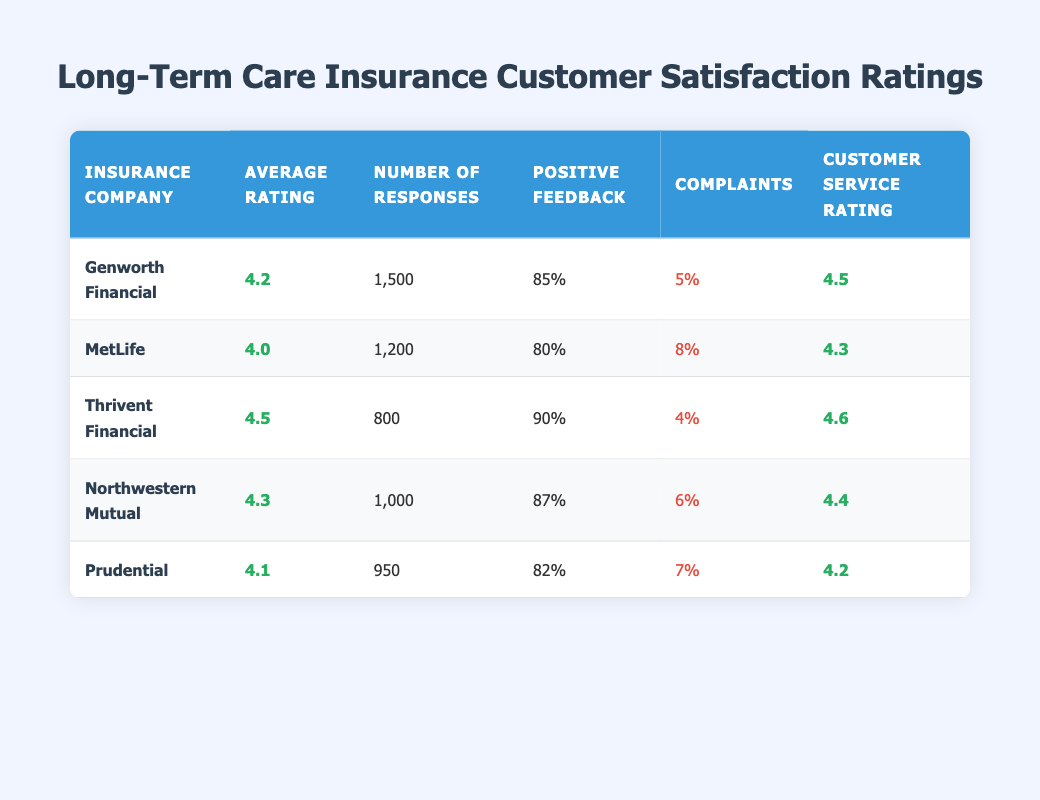What is the average rating for Genworth Financial? The table indicates that the average rating for Genworth Financial is listed under "Average Rating," which is 4.2.
Answer: 4.2 How many responses were received for Prudential? The table shows that the number of responses for Prudential is found under the "Number of Responses," and it is 950.
Answer: 950 Which insurance company received the highest customer service rating? By comparing the "Customer Service Rating" column, Thrivent Financial has the highest customer service rating at 4.6.
Answer: Thrivent Financial What is the total number of responses from all five insurance companies? To find the total, add the number of responses for each company: 1500 + 1200 + 800 + 1000 + 950 = 4450.
Answer: 4450 Is the percentage of positive feedback for MetLife greater than 75%? Looking at the "Positive Feedback" column for MetLife, it shows 80%, which is greater than 75%.
Answer: Yes Which company has the lowest complaints percentage and what is the value? Checking the "Complaints" percentage, Thrivent Financial has the lowest at 4%.
Answer: Thrivent Financial, 4% What is the difference in average ratings between Thrivent Financial and MetLife? Thrivent Financial has an average rating of 4.5 and MetLife has 4.0. The difference is 4.5 - 4.0 = 0.5.
Answer: 0.5 Is there a company that reported less than 5% complaints but more than 85% positive feedback? Yes, Thrivent Financial has a complaints percentage of 4% and positive feedback of 90%.
Answer: Yes What is the average customer service rating across all companies? The average customer service rating can be calculated as follows: (4.5 + 4.3 + 4.6 + 4.4 + 4.2) / 5 = 4.4.
Answer: 4.4 